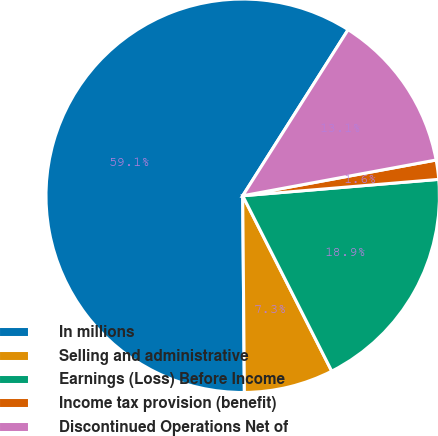Convert chart to OTSL. <chart><loc_0><loc_0><loc_500><loc_500><pie_chart><fcel>In millions<fcel>Selling and administrative<fcel>Earnings (Loss) Before Income<fcel>Income tax provision (benefit)<fcel>Discontinued Operations Net of<nl><fcel>59.13%<fcel>7.34%<fcel>18.85%<fcel>1.58%<fcel>13.09%<nl></chart> 